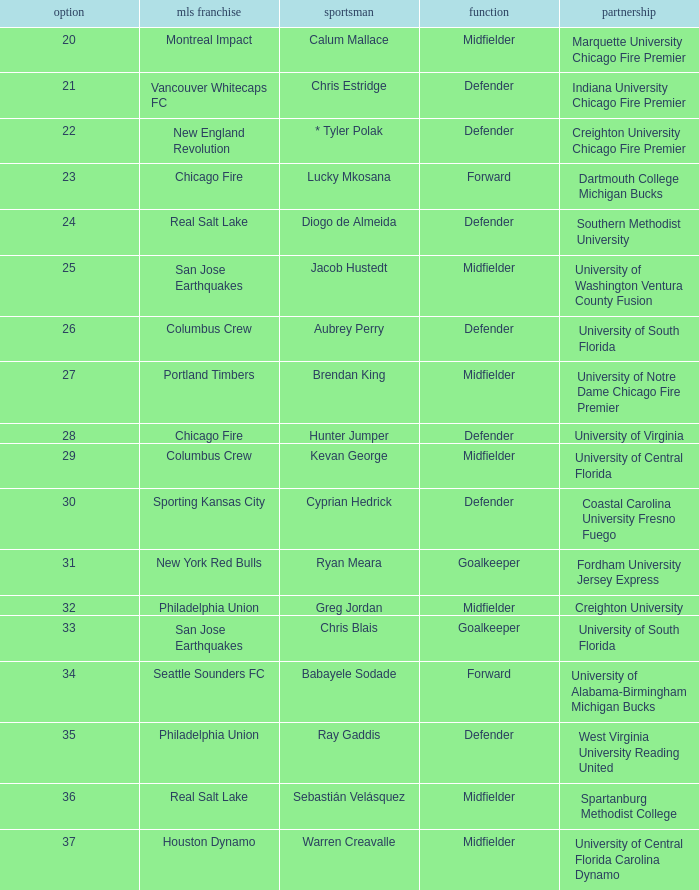What pick number is Kevan George? 29.0. 